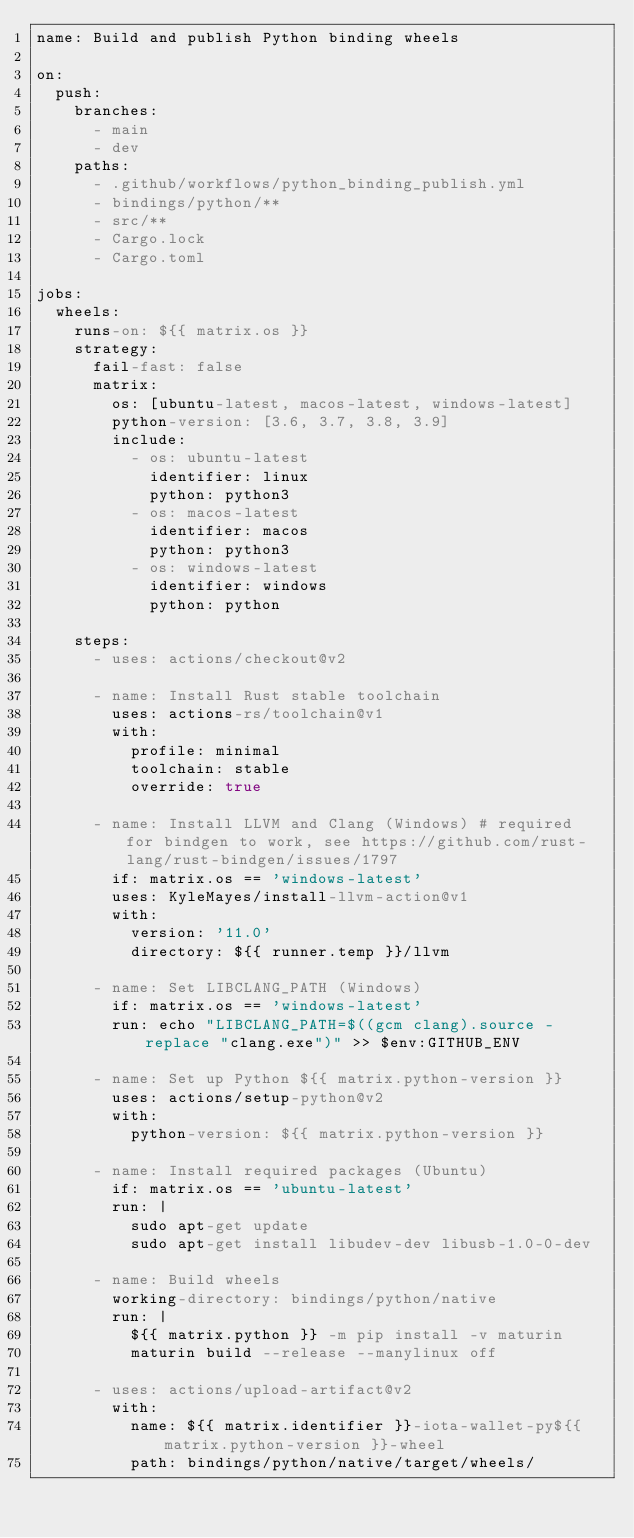<code> <loc_0><loc_0><loc_500><loc_500><_YAML_>name: Build and publish Python binding wheels

on:
  push:
    branches:
      - main
      - dev
    paths:
      - .github/workflows/python_binding_publish.yml
      - bindings/python/**
      - src/**
      - Cargo.lock
      - Cargo.toml

jobs:
  wheels:
    runs-on: ${{ matrix.os }}
    strategy:
      fail-fast: false
      matrix:
        os: [ubuntu-latest, macos-latest, windows-latest]
        python-version: [3.6, 3.7, 3.8, 3.9]
        include:
          - os: ubuntu-latest
            identifier: linux
            python: python3
          - os: macos-latest
            identifier: macos
            python: python3
          - os: windows-latest
            identifier: windows
            python: python

    steps:
      - uses: actions/checkout@v2

      - name: Install Rust stable toolchain
        uses: actions-rs/toolchain@v1
        with:
          profile: minimal
          toolchain: stable
          override: true

      - name: Install LLVM and Clang (Windows) # required for bindgen to work, see https://github.com/rust-lang/rust-bindgen/issues/1797
        if: matrix.os == 'windows-latest'
        uses: KyleMayes/install-llvm-action@v1
        with:
          version: '11.0'
          directory: ${{ runner.temp }}/llvm

      - name: Set LIBCLANG_PATH (Windows)
        if: matrix.os == 'windows-latest'
        run: echo "LIBCLANG_PATH=$((gcm clang).source -replace "clang.exe")" >> $env:GITHUB_ENV

      - name: Set up Python ${{ matrix.python-version }}
        uses: actions/setup-python@v2
        with:
          python-version: ${{ matrix.python-version }}

      - name: Install required packages (Ubuntu)
        if: matrix.os == 'ubuntu-latest'
        run: |
          sudo apt-get update
          sudo apt-get install libudev-dev libusb-1.0-0-dev

      - name: Build wheels
        working-directory: bindings/python/native
        run: |
          ${{ matrix.python }} -m pip install -v maturin
          maturin build --release --manylinux off

      - uses: actions/upload-artifact@v2
        with:
          name: ${{ matrix.identifier }}-iota-wallet-py${{ matrix.python-version }}-wheel
          path: bindings/python/native/target/wheels/
</code> 